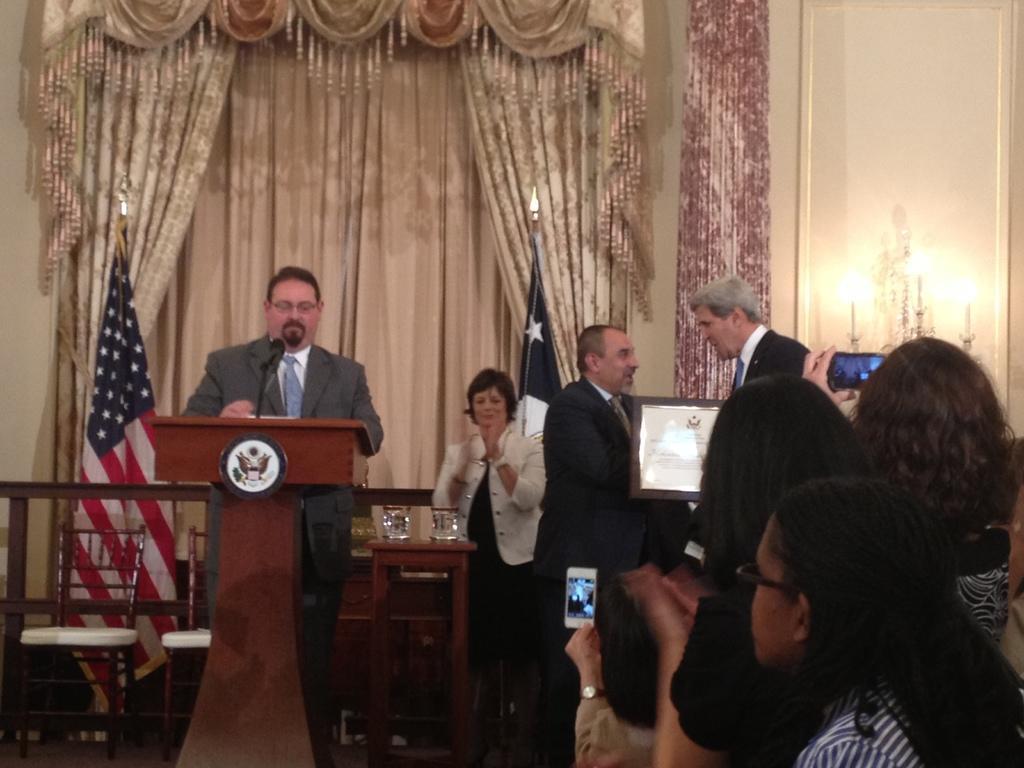In one or two sentences, can you explain what this image depicts? In this image on the left there is a podium ,in front of that there is a man he wear suit and tie. On the right there are many people. In the back ground there is curtain ,light,flag ,woman,chairs and stool. 